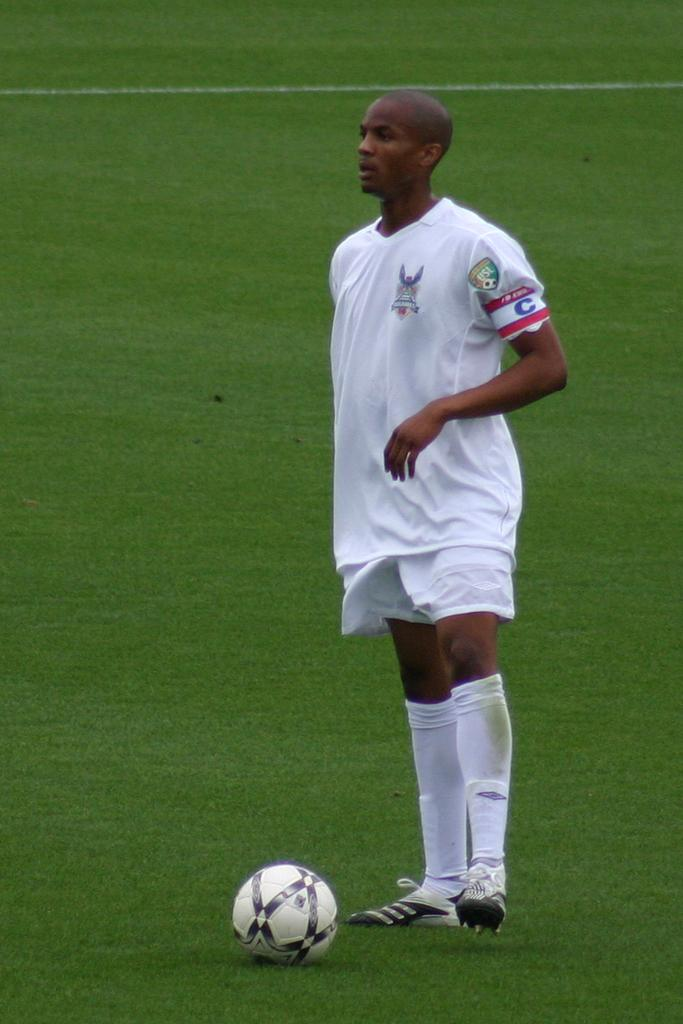What is the main subject of the image? The main subject of the image is a person standing. What is the person standing on? The person is standing on the ground. What type of vegetation is visible in the image? There is grass visible in the image. What object is present in the image besides the person? There is a ball present in the image. What type of bit is the person using to eat their breakfast in the image? There is no reference to a bit or breakfast in the image; it features a person standing on the ground with a ball present. Can you tell me how many airports are visible in the image? There are no airports visible in the image. 